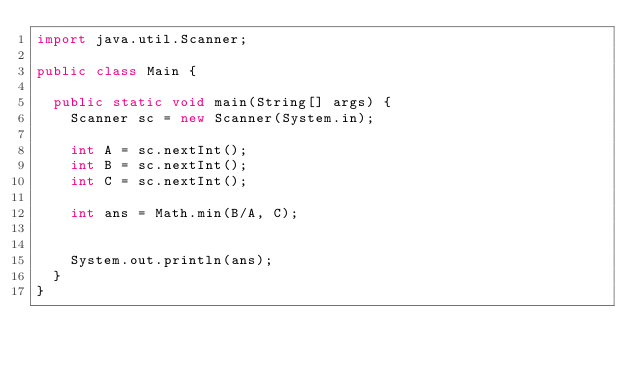<code> <loc_0><loc_0><loc_500><loc_500><_Java_>import java.util.Scanner;

public class Main {
	
	public static void main(String[] args) {
		Scanner sc = new Scanner(System.in);
		
		int A = sc.nextInt();
		int B = sc.nextInt();
		int C = sc.nextInt();
		
		int ans = Math.min(B/A, C);
	
		
		System.out.println(ans);
	}
}
</code> 